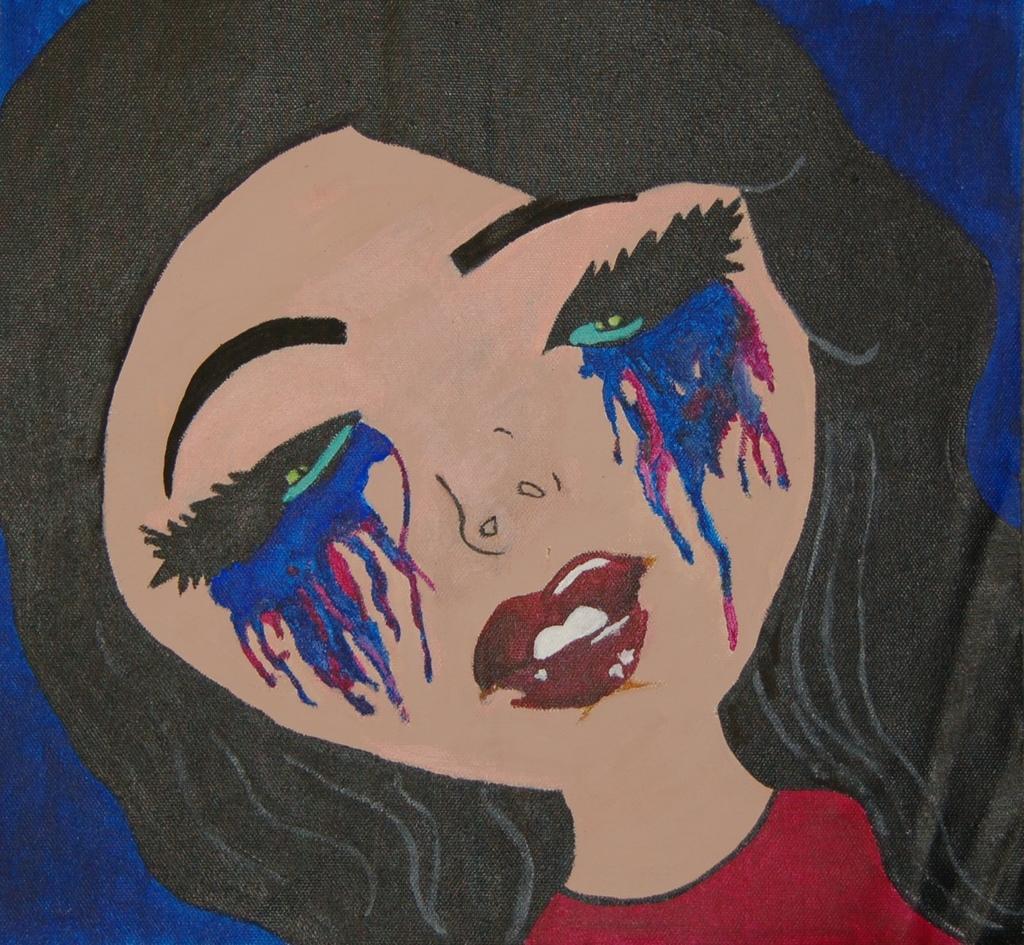Could you give a brief overview of what you see in this image? This is a painting. In this image there is a painting of a woman with red dress. At the back there is a blue background. 